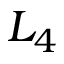Convert formula to latex. <formula><loc_0><loc_0><loc_500><loc_500>L _ { 4 }</formula> 